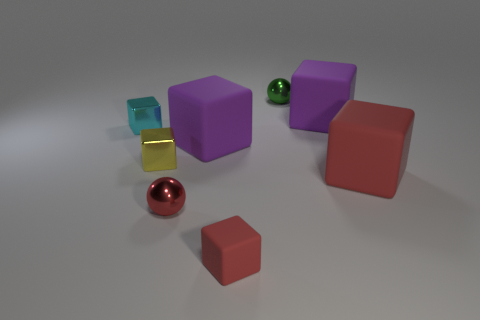How many objects are there in total, and can you describe their colors and shapes? There are six objects in the image. Starting from the left, there's a small transparent blue cube, a small shiny gold bar resembling a rectangular prism, a purple cube, a green sphere with a slight reflective surface, a large red cube, and finally, a small orange-red cube.  The objects seem to be placed on a particular surface. Can you describe it? Certainly, the objects are resting on a flat, matte surface that has a slight gradient of light, suggesting a source of illumination from above. The color of the surface transitions gently from a lighter shade to a darker one, creating a subtle backdrop for the objects. 